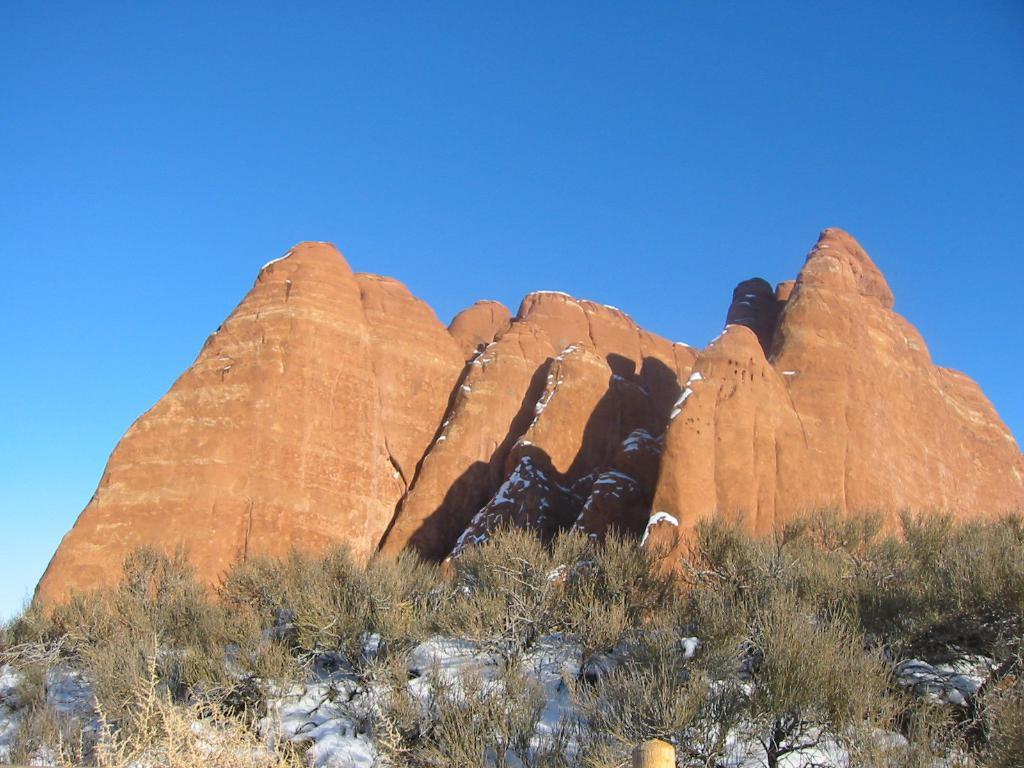What is located in the foreground of the image? There are plants in the foreground of the image. What can be seen in the background of the image? There are hills visible behind the plants in the image. Can you see a monkey driving a car in the image? There is no monkey or car present in the image. What type of spoon is being used by the plants in the image? There are no spoons present in the image, as it features plants in the foreground and hills in the background. 